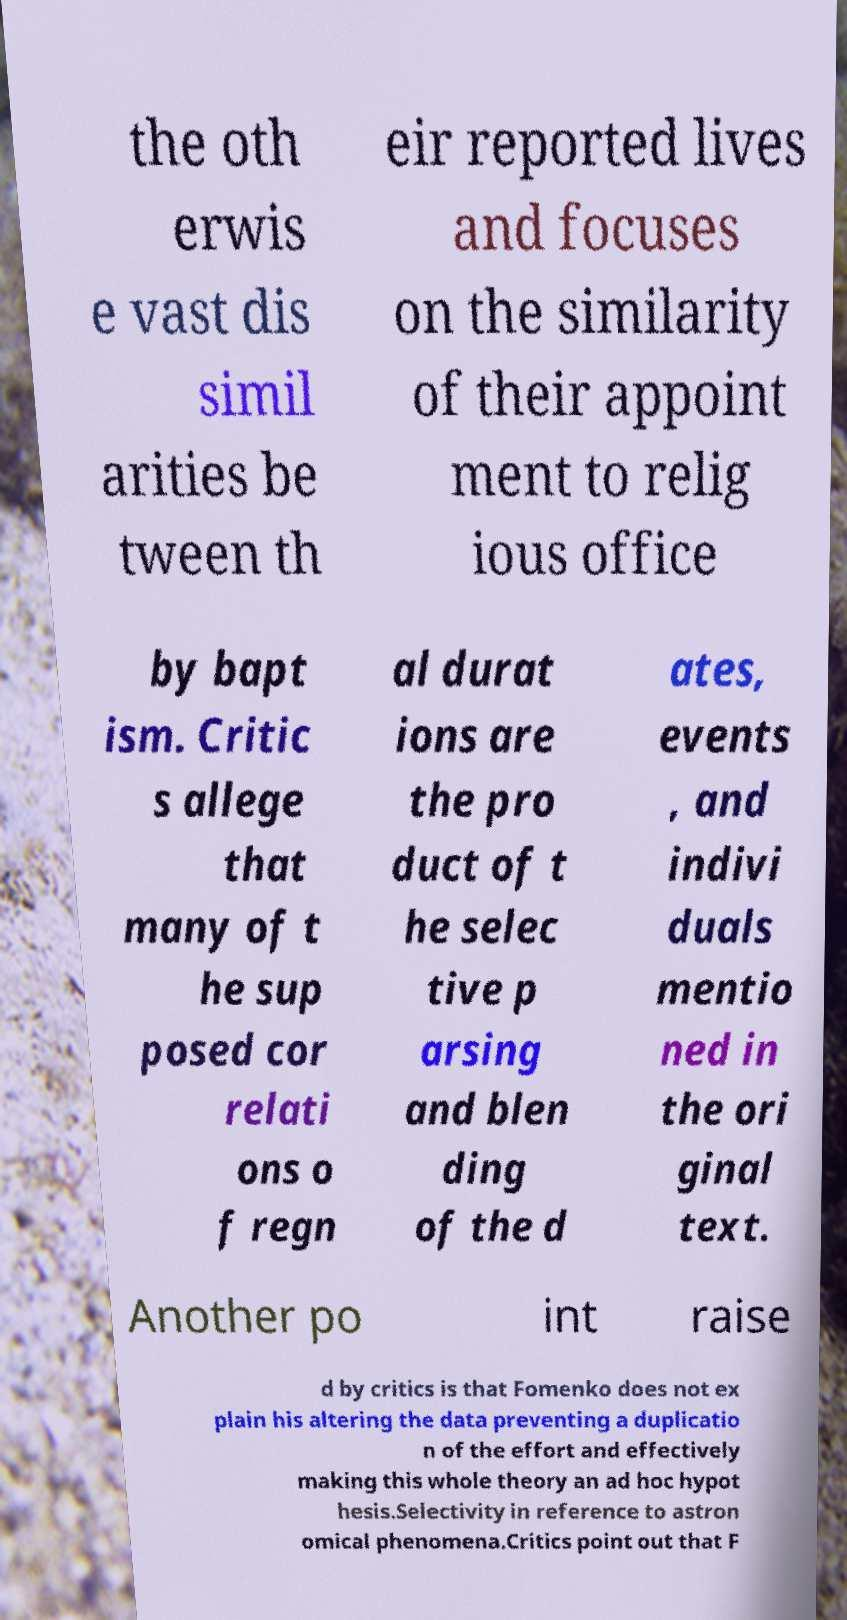Please identify and transcribe the text found in this image. the oth erwis e vast dis simil arities be tween th eir reported lives and focuses on the similarity of their appoint ment to relig ious office by bapt ism. Critic s allege that many of t he sup posed cor relati ons o f regn al durat ions are the pro duct of t he selec tive p arsing and blen ding of the d ates, events , and indivi duals mentio ned in the ori ginal text. Another po int raise d by critics is that Fomenko does not ex plain his altering the data preventing a duplicatio n of the effort and effectively making this whole theory an ad hoc hypot hesis.Selectivity in reference to astron omical phenomena.Critics point out that F 